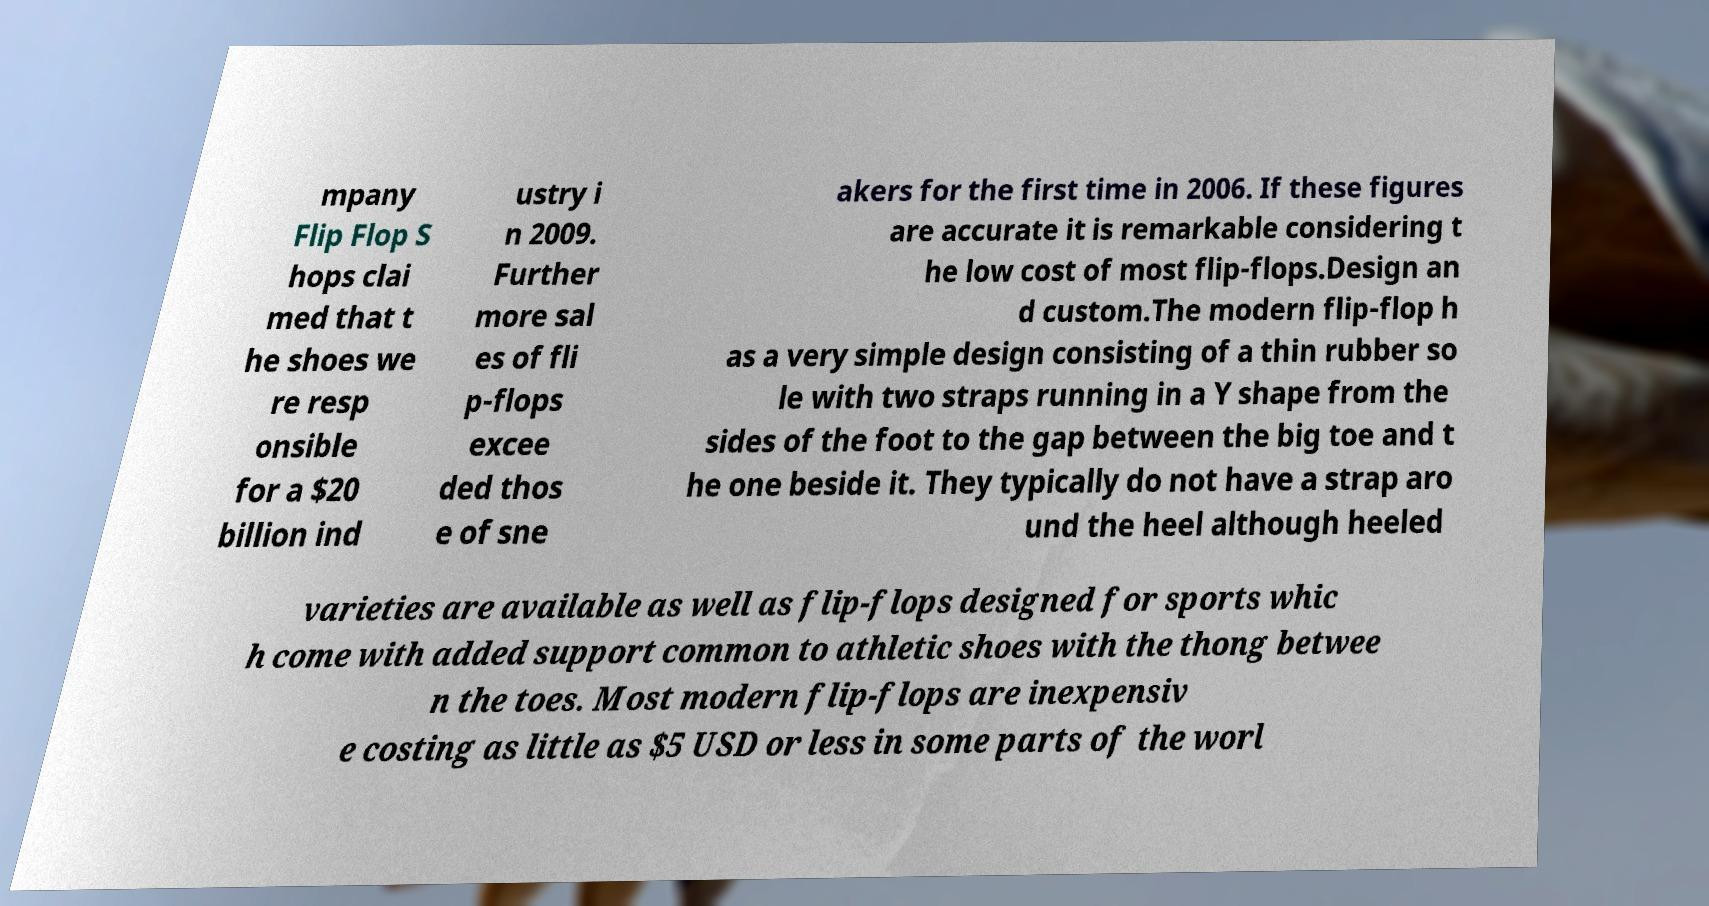For documentation purposes, I need the text within this image transcribed. Could you provide that? mpany Flip Flop S hops clai med that t he shoes we re resp onsible for a $20 billion ind ustry i n 2009. Further more sal es of fli p-flops excee ded thos e of sne akers for the first time in 2006. If these figures are accurate it is remarkable considering t he low cost of most flip-flops.Design an d custom.The modern flip-flop h as a very simple design consisting of a thin rubber so le with two straps running in a Y shape from the sides of the foot to the gap between the big toe and t he one beside it. They typically do not have a strap aro und the heel although heeled varieties are available as well as flip-flops designed for sports whic h come with added support common to athletic shoes with the thong betwee n the toes. Most modern flip-flops are inexpensiv e costing as little as $5 USD or less in some parts of the worl 